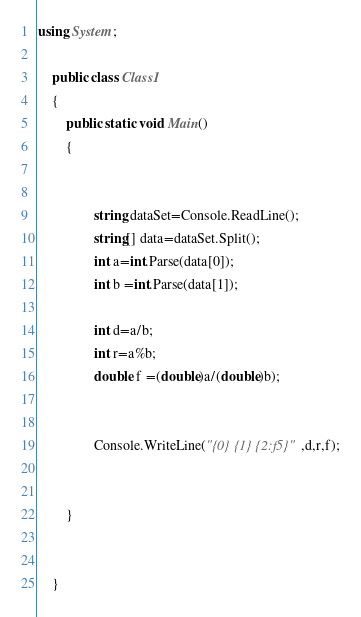Convert code to text. <code><loc_0><loc_0><loc_500><loc_500><_C#_>using System;

	public class Class1
	{
		public static void Main()
		{   
		
			
				string dataSet=Console.ReadLine();
				string[] data=dataSet.Split();
				int a=int.Parse(data[0]);
				int b =int.Parse(data[1]);
				
				int d=a/b;
				int r=a%b;
				double f =(double)a/(double)b);
				
			
				Console.WriteLine("{0} {1} {2:f5}",d,r,f);
			
			
		}
	

	}</code> 